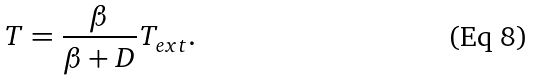Convert formula to latex. <formula><loc_0><loc_0><loc_500><loc_500>T = \frac { \beta } { \beta + D } T _ { e x t } .</formula> 